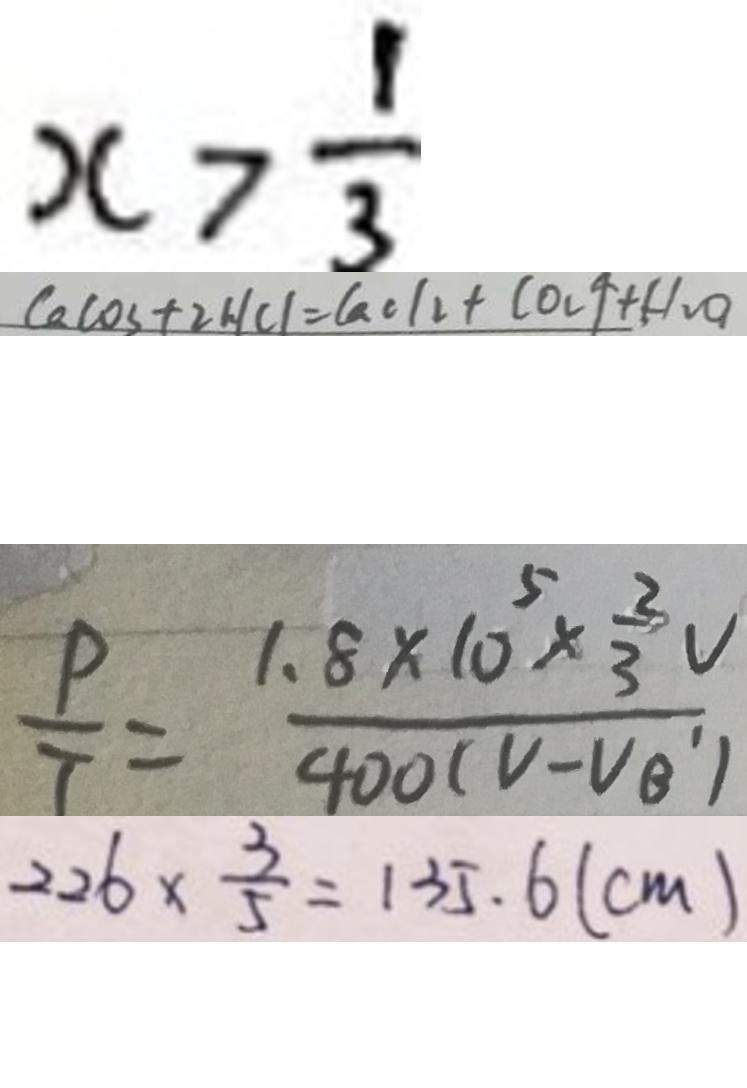<formula> <loc_0><loc_0><loc_500><loc_500>x > \frac { 1 } { 3 } 
 C a C O _ { 3 } + 2 H C l = C a C l _ { 2 } + C O _ { 2 } \uparrow + H _ { 2 } O 
 \frac { P } { T } = \frac { 1 . 8 \times 1 0 ^ { 5 } \times \frac { 2 } { 3 } V } { 4 0 0 ( V - V _ { B ^ { \prime } } ) } 
 2 2 6 \times \frac { 3 } { 5 } = 1 3 5 . 6 ( c m )</formula> 